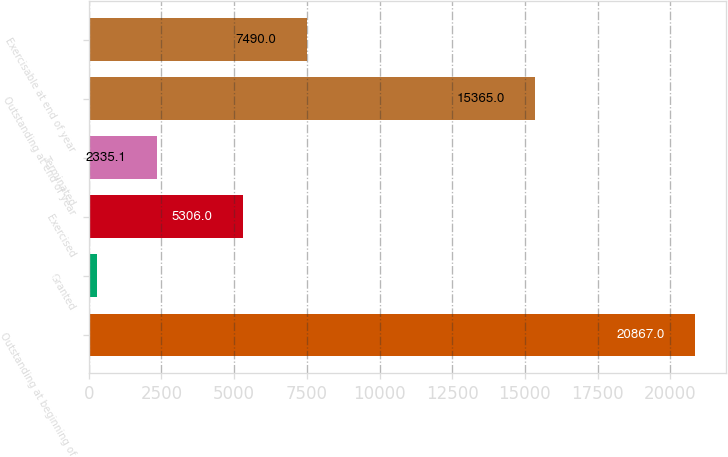Convert chart to OTSL. <chart><loc_0><loc_0><loc_500><loc_500><bar_chart><fcel>Outstanding at beginning of<fcel>Granted<fcel>Exercised<fcel>Terminated<fcel>Outstanding at end of year<fcel>Exercisable at end of year<nl><fcel>20867<fcel>276<fcel>5306<fcel>2335.1<fcel>15365<fcel>7490<nl></chart> 